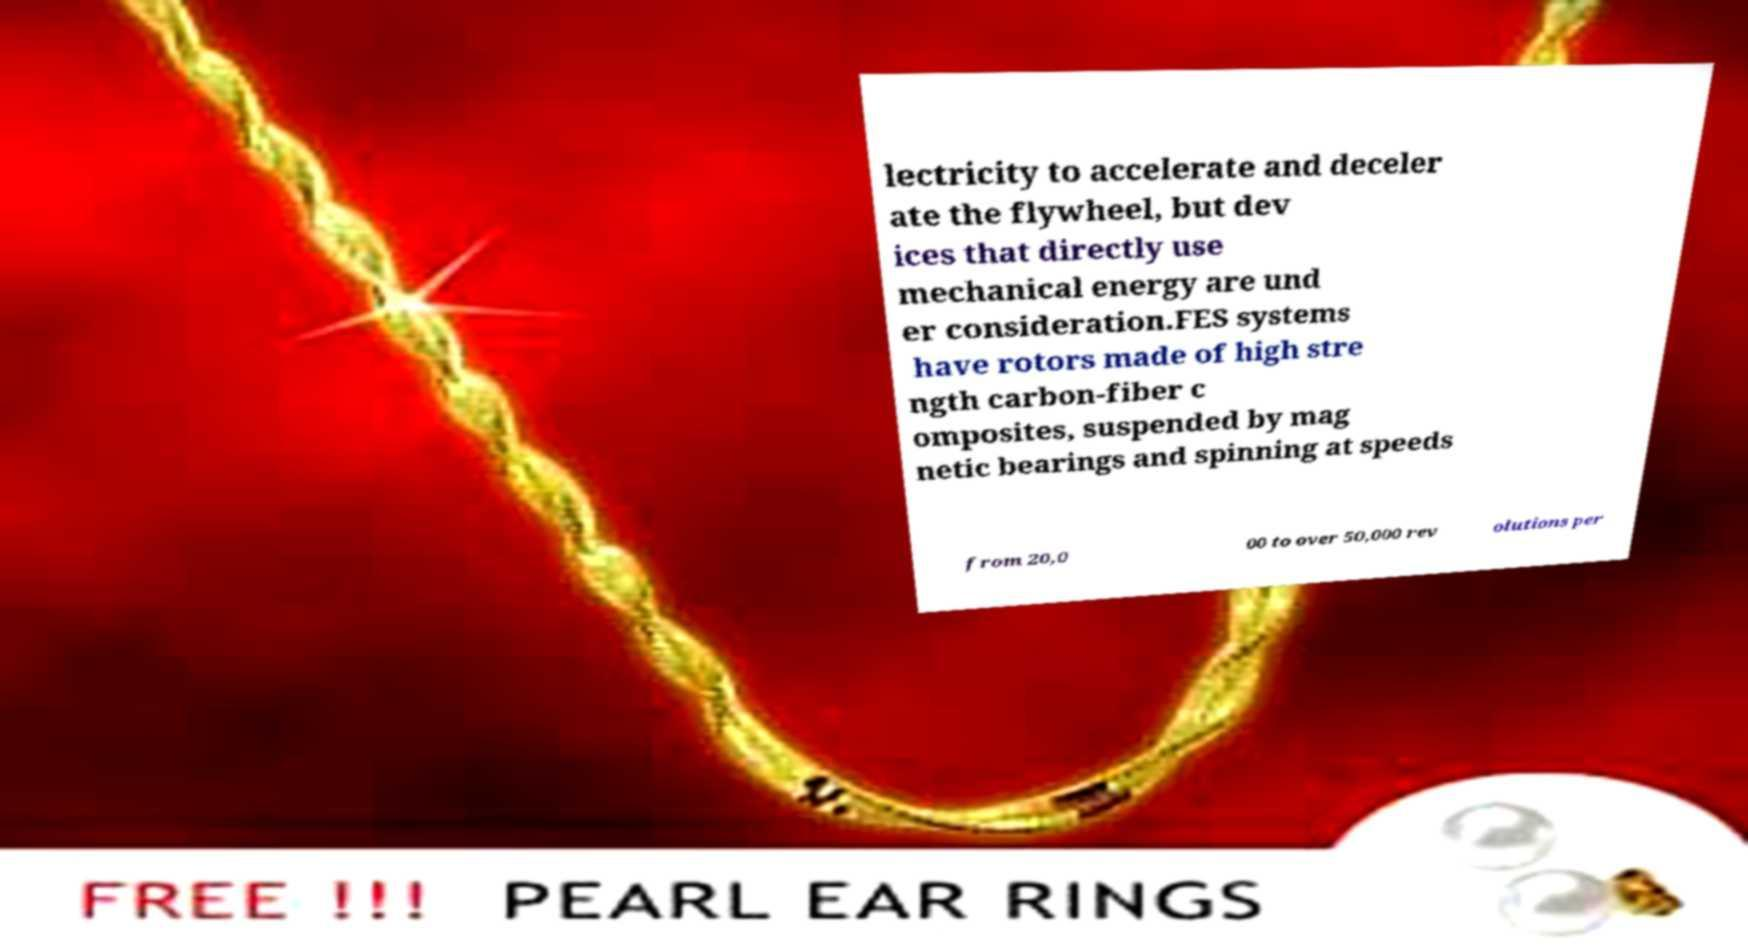Could you assist in decoding the text presented in this image and type it out clearly? lectricity to accelerate and deceler ate the flywheel, but dev ices that directly use mechanical energy are und er consideration.FES systems have rotors made of high stre ngth carbon-fiber c omposites, suspended by mag netic bearings and spinning at speeds from 20,0 00 to over 50,000 rev olutions per 